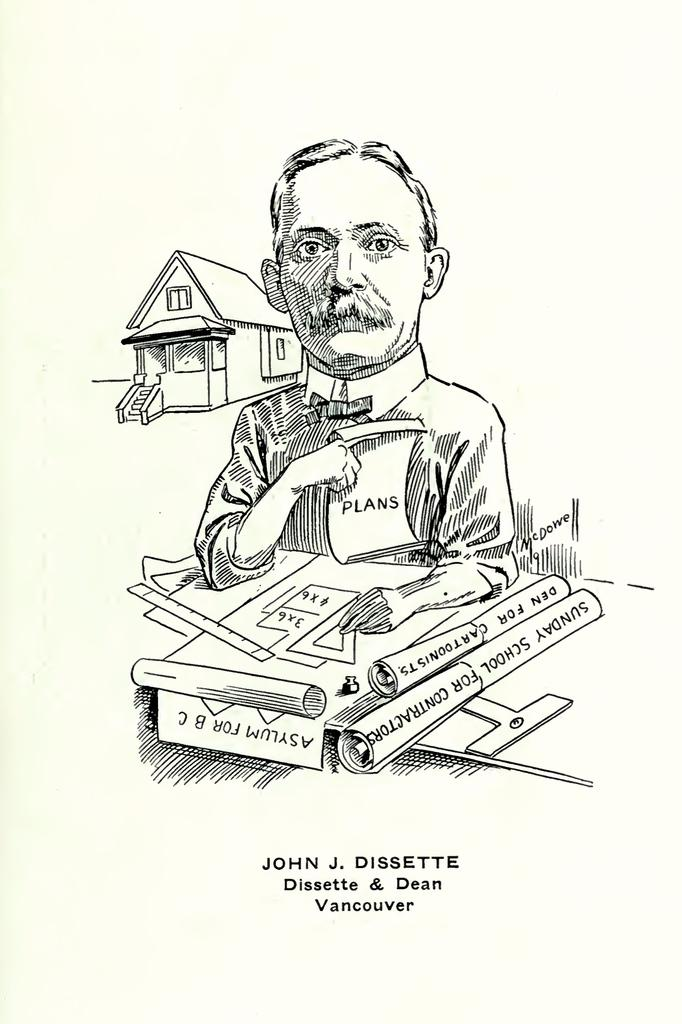What is the main subject of the drawing in the image? The drawing contains a person and a house. What other objects are present in the drawing? The drawing contains many objects. Is there any text associated with the drawing in the image? Yes, there is text written at the bottom of the image. How many trees are visible in the drawing? There is no mention of trees in the drawing or the image. 